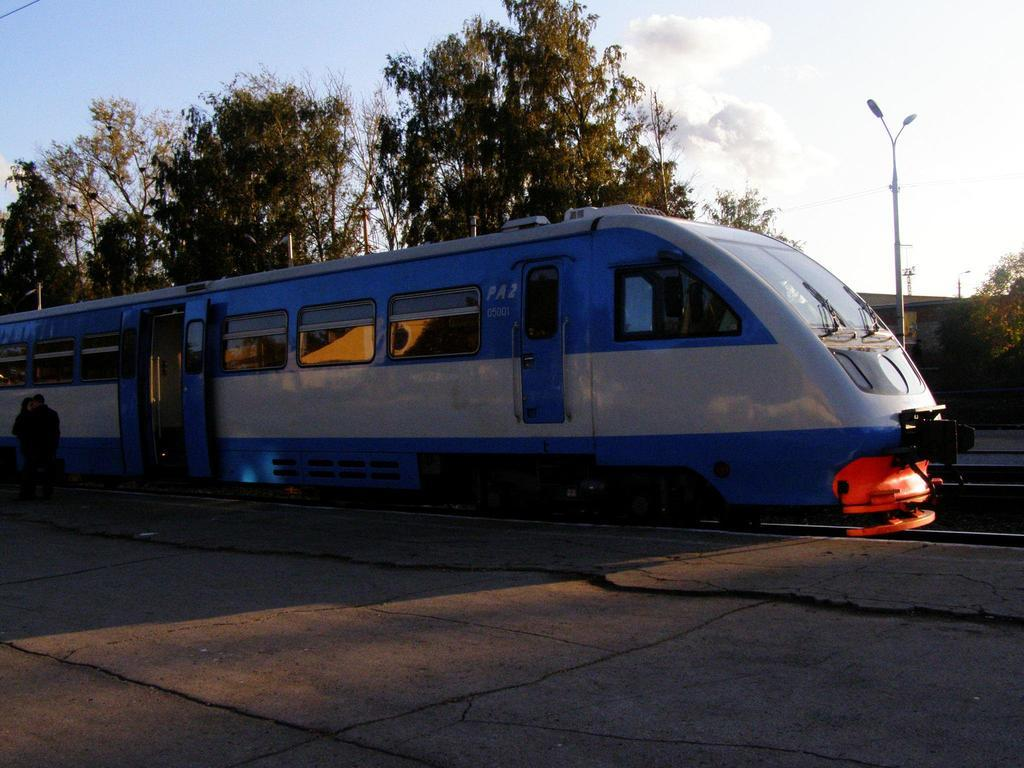What type of vehicle is in the image? There is a blue train in the image. What is located at the bottom of the image? There is a platform at the bottom of the image. What can be seen in the background of the image? There are trees in the background of the image. What is visible in the sky at the top of the image? There are clouds in the sky at the top of the image. How many passengers are swimming in the image? There are no passengers or swimming activity present in the image. 